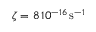<formula> <loc_0><loc_0><loc_500><loc_500>\zeta = 8 \, 1 0 ^ { - 1 6 } \, s ^ { - 1 }</formula> 